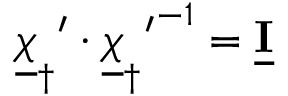<formula> <loc_0><loc_0><loc_500><loc_500>{ { \underline { \chi } _ { \dagger } } ^ { \prime } \cdot { { \underline { \chi } _ { \dagger } } ^ { \prime } } ^ { - 1 } = \underline { \mathbf I } }</formula> 